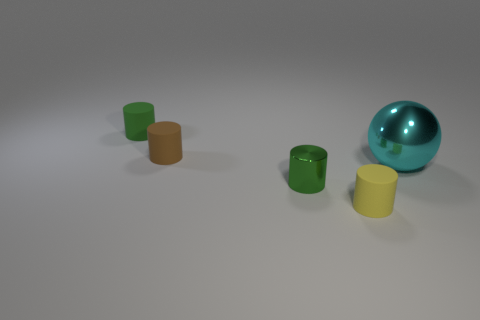Is there any other thing that is the same size as the cyan metallic sphere?
Provide a succinct answer. No. Are there any green things made of the same material as the big cyan ball?
Your answer should be very brief. Yes. The small rubber thing right of the shiny object left of the shiny thing that is to the right of the small yellow thing is what shape?
Your response must be concise. Cylinder. Is the color of the matte thing in front of the big ball the same as the metallic thing that is in front of the large cyan metallic sphere?
Offer a very short reply. No. There is a brown matte thing; are there any cyan things in front of it?
Provide a succinct answer. Yes. How many tiny green matte things have the same shape as the tiny yellow thing?
Keep it short and to the point. 1. What color is the metal thing to the left of the rubber cylinder that is in front of the thing that is on the right side of the small yellow matte cylinder?
Provide a succinct answer. Green. Do the tiny green cylinder that is behind the cyan shiny object and the small object that is in front of the small metal object have the same material?
Your response must be concise. Yes. How many objects are either tiny cylinders that are in front of the big cyan thing or large rubber cylinders?
Provide a succinct answer. 2. What number of objects are either large gray metallic objects or tiny things in front of the green matte cylinder?
Offer a very short reply. 3. 